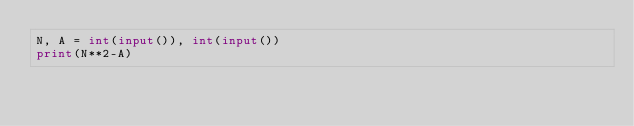Convert code to text. <code><loc_0><loc_0><loc_500><loc_500><_Python_>N, A = int(input()), int(input())
print(N**2-A)</code> 